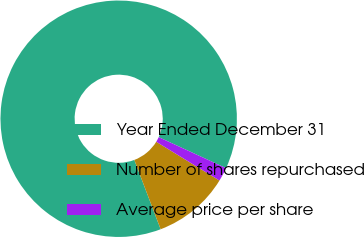Convert chart to OTSL. <chart><loc_0><loc_0><loc_500><loc_500><pie_chart><fcel>Year Ended December 31<fcel>Number of shares repurchased<fcel>Average price per share<nl><fcel>87.64%<fcel>10.47%<fcel>1.89%<nl></chart> 